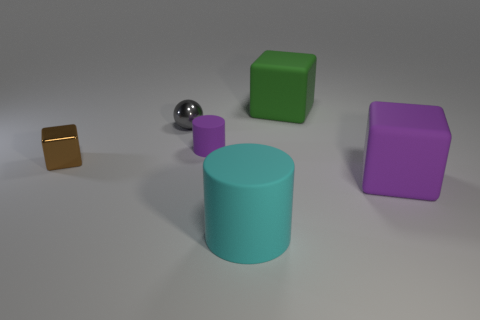What is the green object made of?
Give a very brief answer. Rubber. Is the block that is on the left side of the big green matte object made of the same material as the small cylinder?
Keep it short and to the point. No. There is a tiny shiny object on the right side of the small brown metal cube; what shape is it?
Make the answer very short. Sphere. There is a green object that is the same size as the cyan rubber cylinder; what material is it?
Ensure brevity in your answer.  Rubber. How many objects are objects that are behind the tiny brown object or cubes in front of the big green matte cube?
Provide a succinct answer. 5. What is the size of the other purple object that is the same material as the large purple object?
Offer a terse response. Small. What number of metallic objects are either purple cylinders or green objects?
Offer a very short reply. 0. What size is the brown thing?
Your answer should be very brief. Small. Does the brown shiny cube have the same size as the green matte thing?
Your answer should be compact. No. There is a cube behind the tiny block; what is its material?
Give a very brief answer. Rubber. 